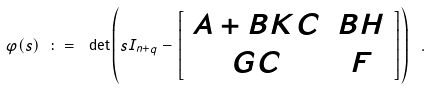Convert formula to latex. <formula><loc_0><loc_0><loc_500><loc_500>\varphi ( s ) \ \colon = \ \det \left ( s I _ { n + q } - \left [ \begin{array} { c c } A + B K C & B H \\ G C & F \end{array} \right ] \right ) \ .</formula> 